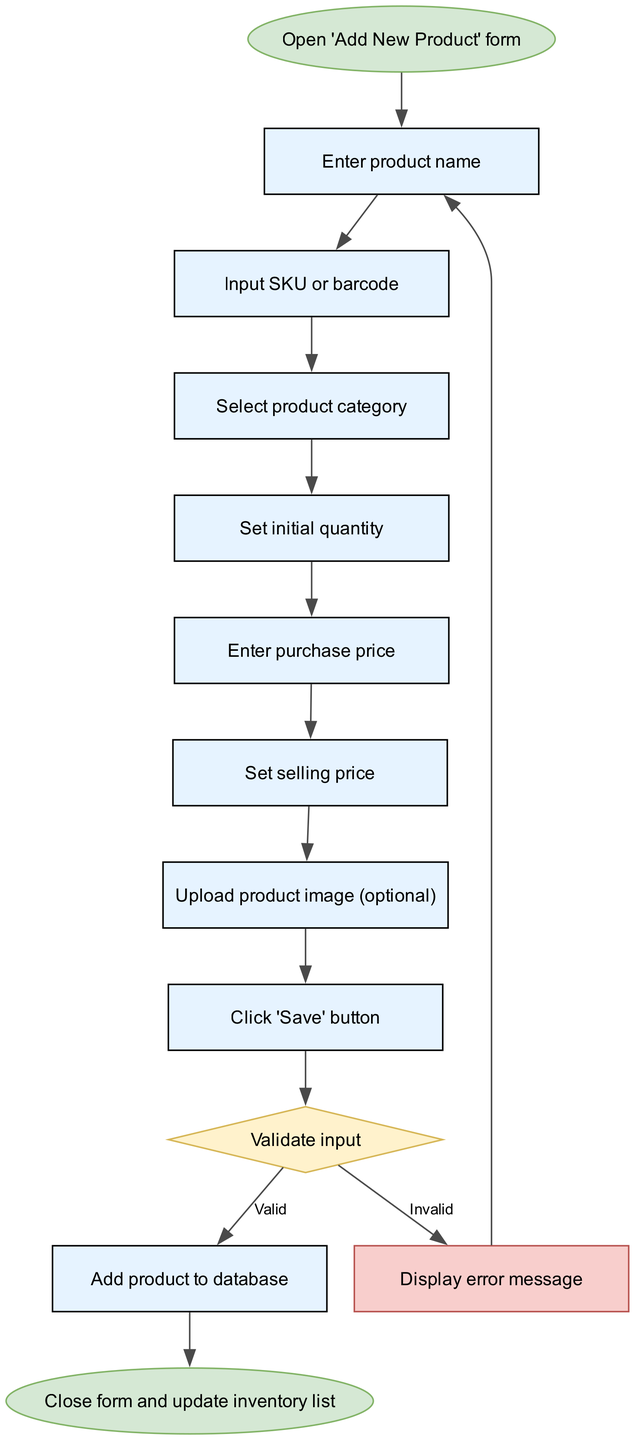What is the first step in the process? The diagram indicates that the first step is to "Open 'Add New Product' form," which is labeled at the starting point.
Answer: Open 'Add New Product' form How many steps are there before the decision node? By counting the connections leading up to the decision node, we see there are 8 steps: from 'Open form' to 'Click 'Save' button.'
Answer: 8 What happens if the input is valid? If the input is valid, the flow proceeds from the decision node to the 'Add product to database' node, indicating successful validation.
Answer: Add product to database What is displayed if an error occurs during input validation? The diagram specifies that an error message is displayed following an invalid decision, leading back to the step to enter the product name again.
Answer: Display error message Which step allows for an optional action? The step titled "Upload product image (optional)" indicates that uploading a product image is not required but can be performed if desired.
Answer: Upload product image (optional) What is the final outcome of completing the entire process? At the end of the flow, the process concludes with "Close form and update inventory list," marking the completion after adding the product.
Answer: Close form and update inventory list What is the relationship between the ‘Click ’Save’ button’ and ‘Validate input’? The ‘Click 'Save' button’ is a precursor, meaning it leads directly to the validation of input, indicating that saving initiates the validation process.
Answer: Leads to validation After an error message, what step does the user return to? Following the display of an error message, the user is directed back to the initial step of entering the product name, allowing them to correct any mistakes.
Answer: Enter product name 